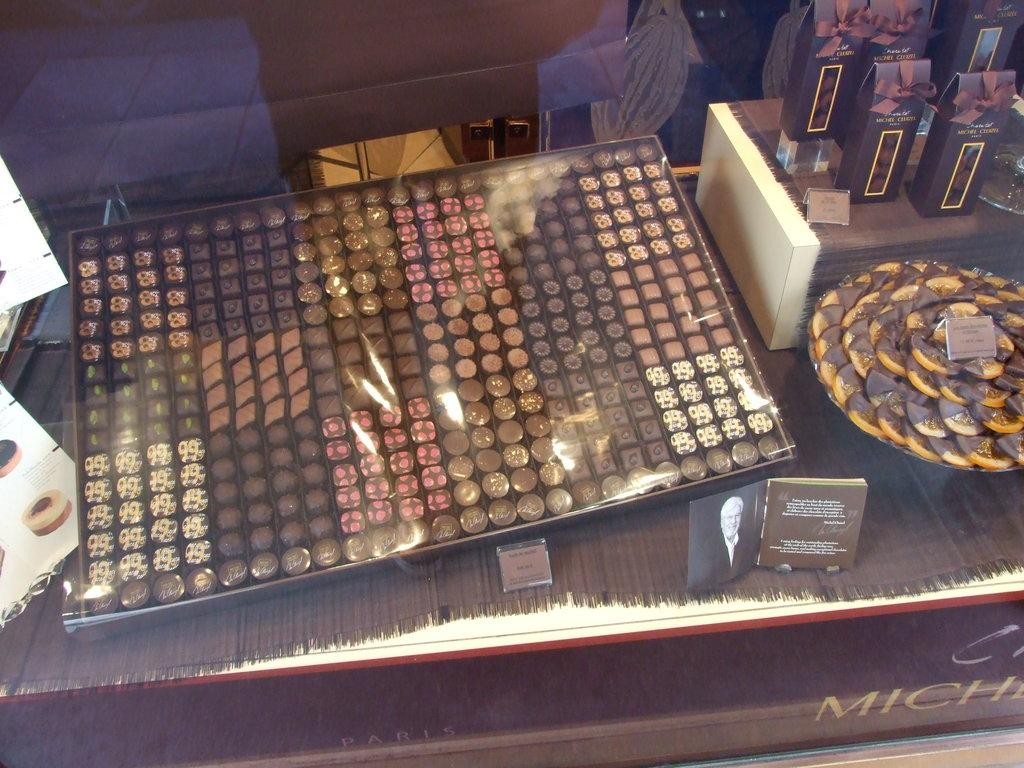What type of food can be seen in the tray in the image? There are sweets in the tray in the image. What is located on the surface in the image? There is a bowl on the surface in the image. What is inside the bowl? The bowl contains sweets. What can be seen in the background of the image? There are boards visible in the image. Can you describe any other objects present in the image? There are additional objects present in the image, but their specific details are not mentioned in the provided facts. How many ants are crawling on the sweets in the image? There are no ants present in the image; it only shows sweets in a tray and a bowl. What color is the ladybug on the board in the image? There is no ladybug present in the image; it only shows sweets, a bowl, and boards. 